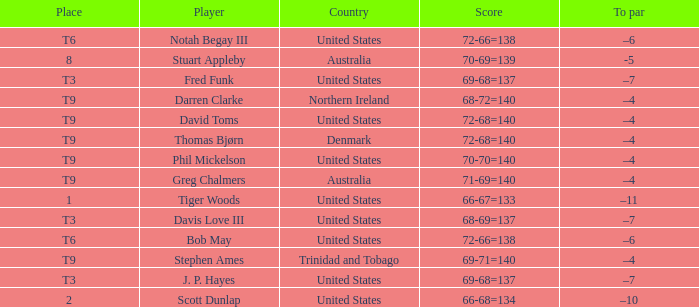What country is Darren Clarke from? Northern Ireland. 